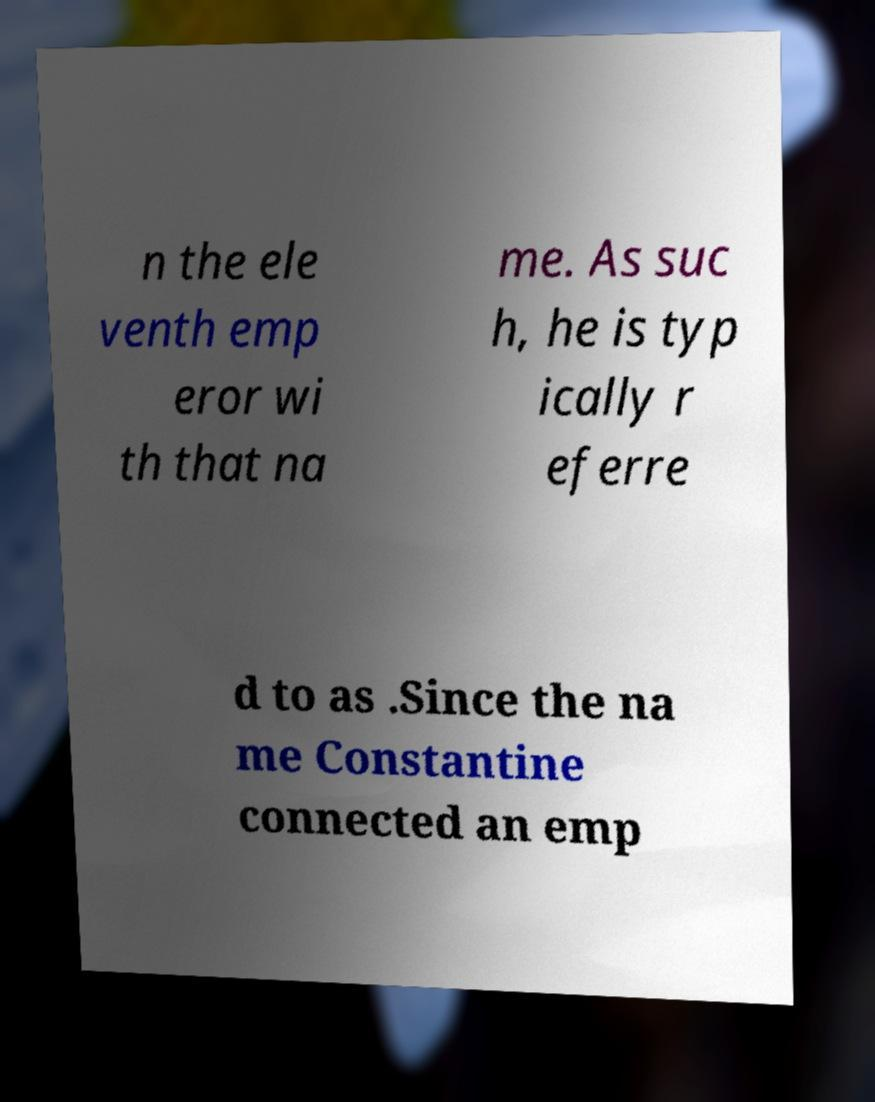Can you read and provide the text displayed in the image?This photo seems to have some interesting text. Can you extract and type it out for me? n the ele venth emp eror wi th that na me. As suc h, he is typ ically r eferre d to as .Since the na me Constantine connected an emp 